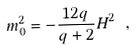<formula> <loc_0><loc_0><loc_500><loc_500>m ^ { 2 } _ { 0 } = - \frac { 1 2 q } { q + 2 } H ^ { 2 } \ ,</formula> 